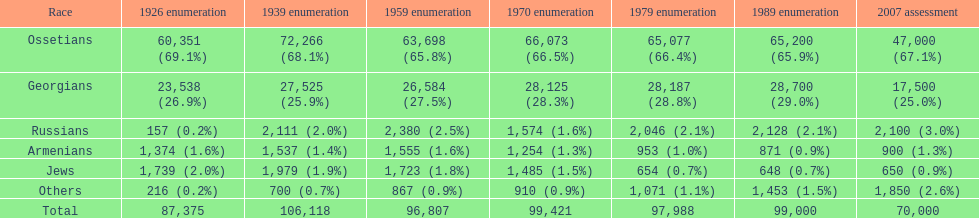How many ethnicities were below 1,000 people in 2007? 2. Give me the full table as a dictionary. {'header': ['Race', '1926 enumeration', '1939 enumeration', '1959 enumeration', '1970 enumeration', '1979 enumeration', '1989 enumeration', '2007 assessment'], 'rows': [['Ossetians', '60,351 (69.1%)', '72,266 (68.1%)', '63,698 (65.8%)', '66,073 (66.5%)', '65,077 (66.4%)', '65,200 (65.9%)', '47,000 (67.1%)'], ['Georgians', '23,538 (26.9%)', '27,525 (25.9%)', '26,584 (27.5%)', '28,125 (28.3%)', '28,187 (28.8%)', '28,700 (29.0%)', '17,500 (25.0%)'], ['Russians', '157 (0.2%)', '2,111 (2.0%)', '2,380 (2.5%)', '1,574 (1.6%)', '2,046 (2.1%)', '2,128 (2.1%)', '2,100 (3.0%)'], ['Armenians', '1,374 (1.6%)', '1,537 (1.4%)', '1,555 (1.6%)', '1,254 (1.3%)', '953 (1.0%)', '871 (0.9%)', '900 (1.3%)'], ['Jews', '1,739 (2.0%)', '1,979 (1.9%)', '1,723 (1.8%)', '1,485 (1.5%)', '654 (0.7%)', '648 (0.7%)', '650 (0.9%)'], ['Others', '216 (0.2%)', '700 (0.7%)', '867 (0.9%)', '910 (0.9%)', '1,071 (1.1%)', '1,453 (1.5%)', '1,850 (2.6%)'], ['Total', '87,375', '106,118', '96,807', '99,421', '97,988', '99,000', '70,000']]} 